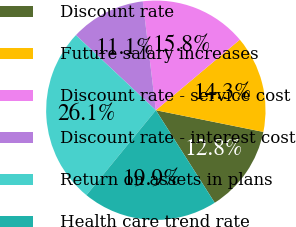Convert chart to OTSL. <chart><loc_0><loc_0><loc_500><loc_500><pie_chart><fcel>Discount rate<fcel>Future salary increases<fcel>Discount rate - service cost<fcel>Discount rate - interest cost<fcel>Return on assets in plans<fcel>Health care trend rate<nl><fcel>12.81%<fcel>14.29%<fcel>15.78%<fcel>11.1%<fcel>26.09%<fcel>19.92%<nl></chart> 